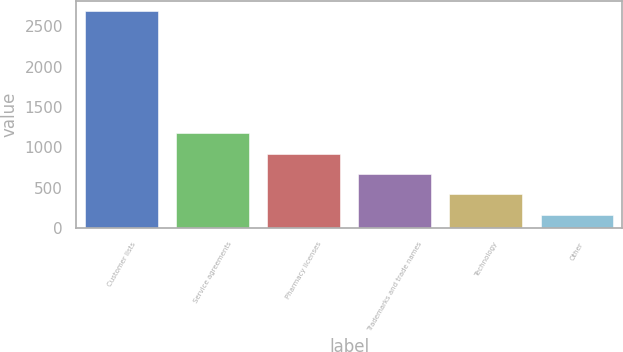<chart> <loc_0><loc_0><loc_500><loc_500><bar_chart><fcel>Customer lists<fcel>Service agreements<fcel>Pharmacy licenses<fcel>Trademarks and trade names<fcel>Technology<fcel>Other<nl><fcel>2683<fcel>1170.4<fcel>918.3<fcel>666.2<fcel>414.1<fcel>162<nl></chart> 